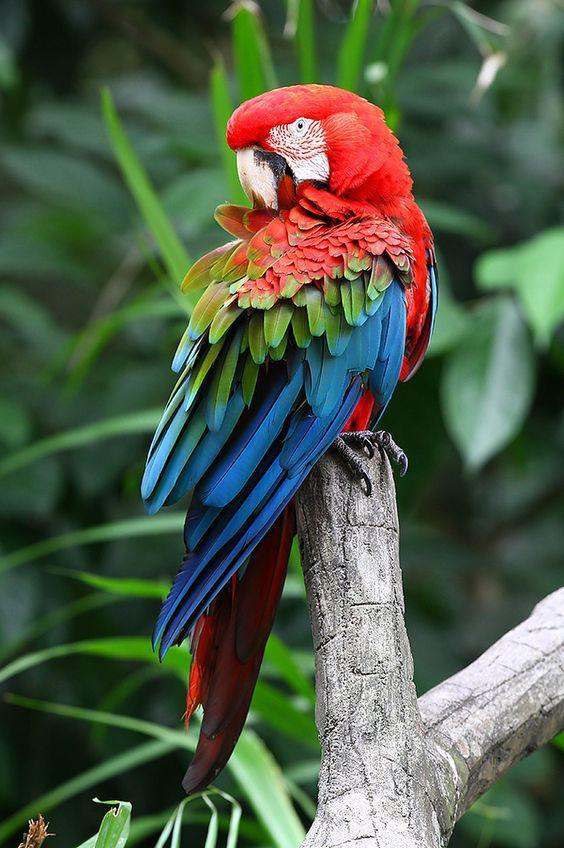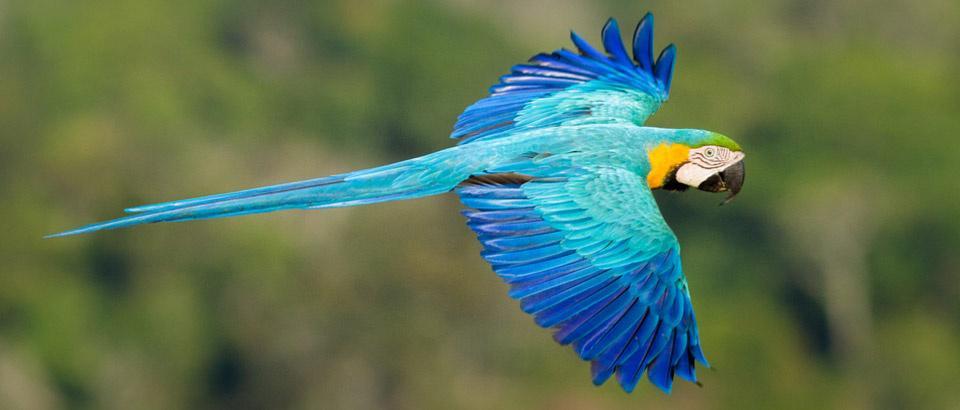The first image is the image on the left, the second image is the image on the right. Analyze the images presented: Is the assertion "The bird in the image on the right has its wings spread." valid? Answer yes or no. Yes. The first image is the image on the left, the second image is the image on the right. Examine the images to the left and right. Is the description "One image contains a bird with spread wings, and the other image shows a perching bird with a red head." accurate? Answer yes or no. Yes. 